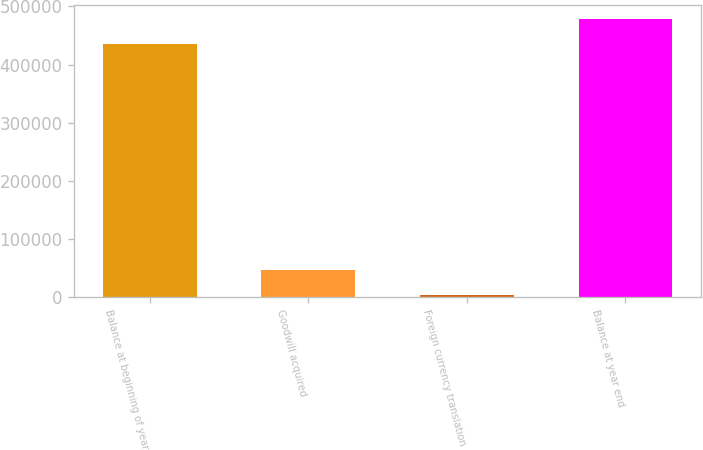Convert chart to OTSL. <chart><loc_0><loc_0><loc_500><loc_500><bar_chart><fcel>Balance at beginning of year<fcel>Goodwill acquired<fcel>Foreign currency translation<fcel>Balance at year end<nl><fcel>434699<fcel>46917.2<fcel>2381<fcel>479235<nl></chart> 